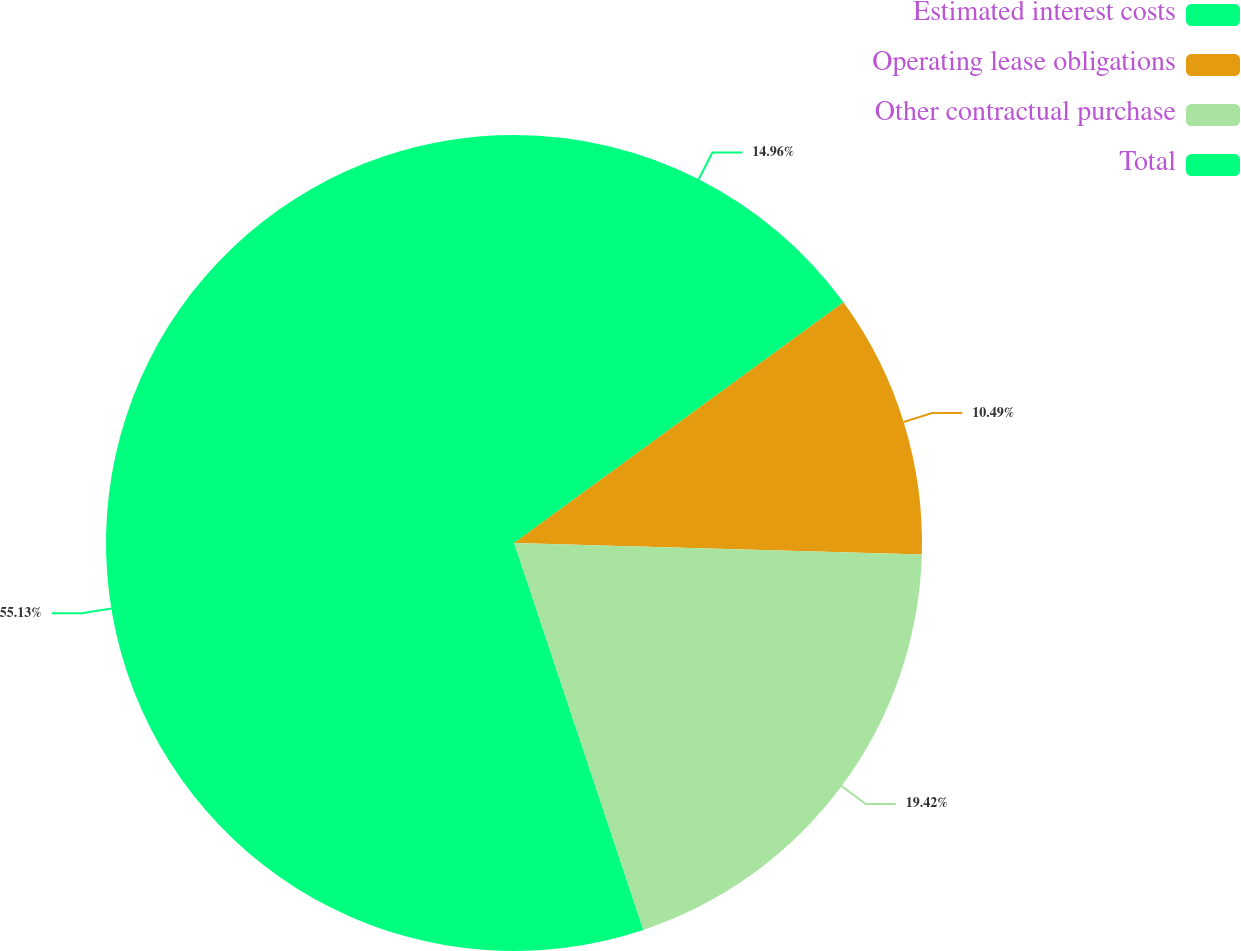<chart> <loc_0><loc_0><loc_500><loc_500><pie_chart><fcel>Estimated interest costs<fcel>Operating lease obligations<fcel>Other contractual purchase<fcel>Total<nl><fcel>14.96%<fcel>10.49%<fcel>19.42%<fcel>55.13%<nl></chart> 